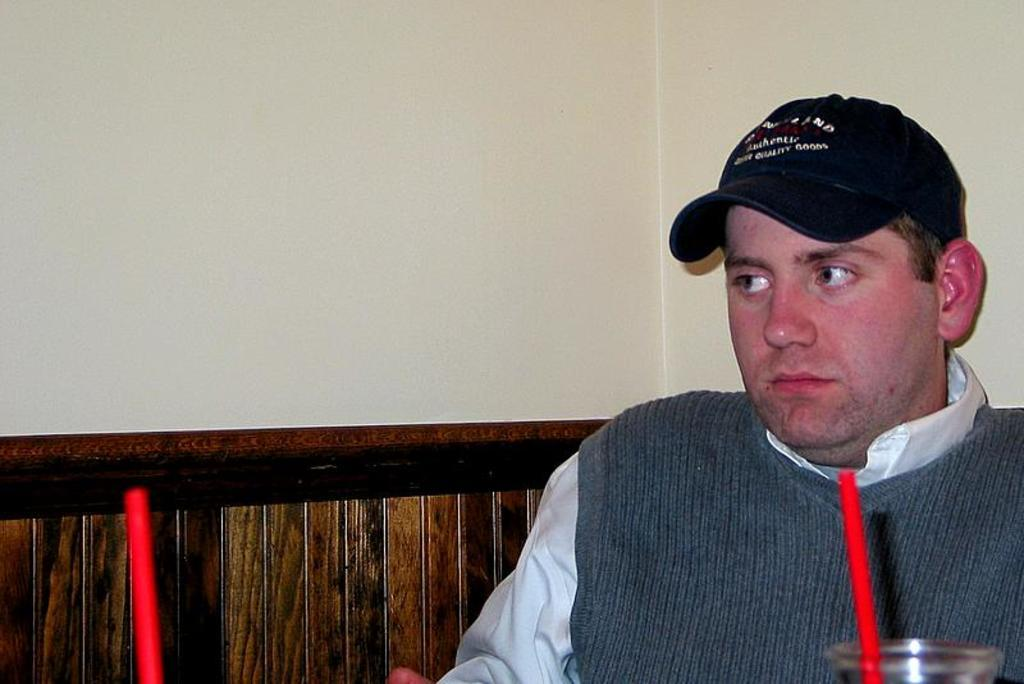Who is the main subject in the foreground of the image? There is a man in the foreground of the image. On which side of the image is the man located? The man is on the right side of the image. What can be seen in the image besides the man? There is a glass with a red straw in the image, another red straw on the left side of the image, a wooden seat, and a wall. What type of wine is being served in the image? There is no wine present in the image. 